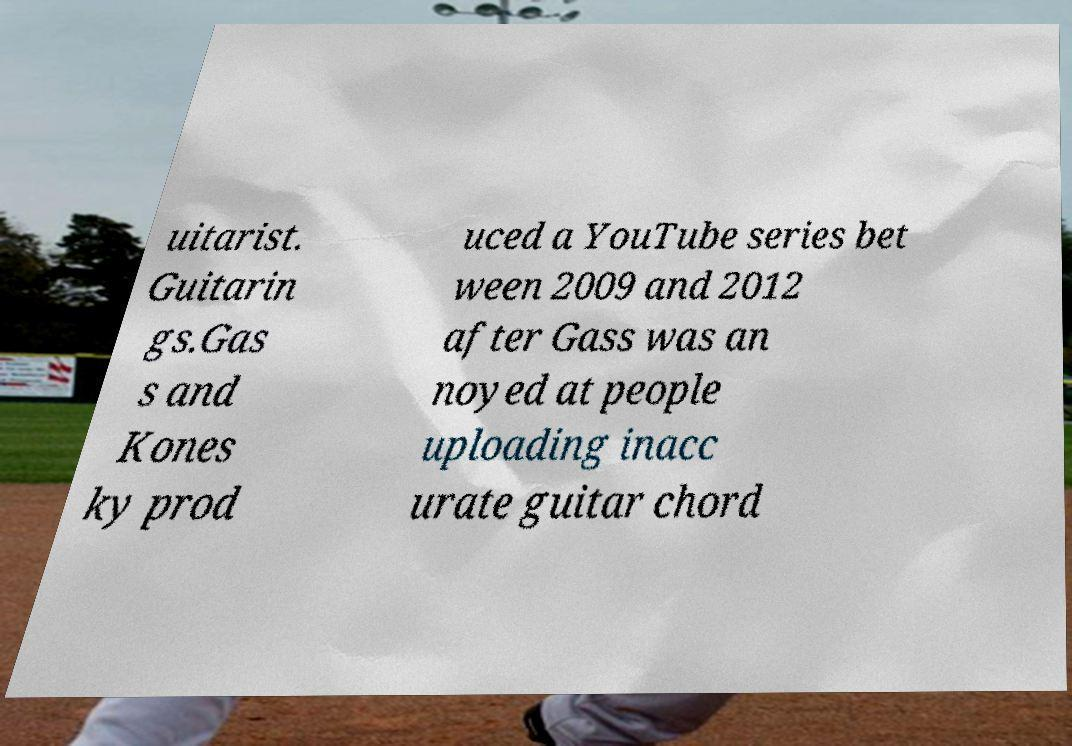Can you read and provide the text displayed in the image?This photo seems to have some interesting text. Can you extract and type it out for me? uitarist. Guitarin gs.Gas s and Kones ky prod uced a YouTube series bet ween 2009 and 2012 after Gass was an noyed at people uploading inacc urate guitar chord 